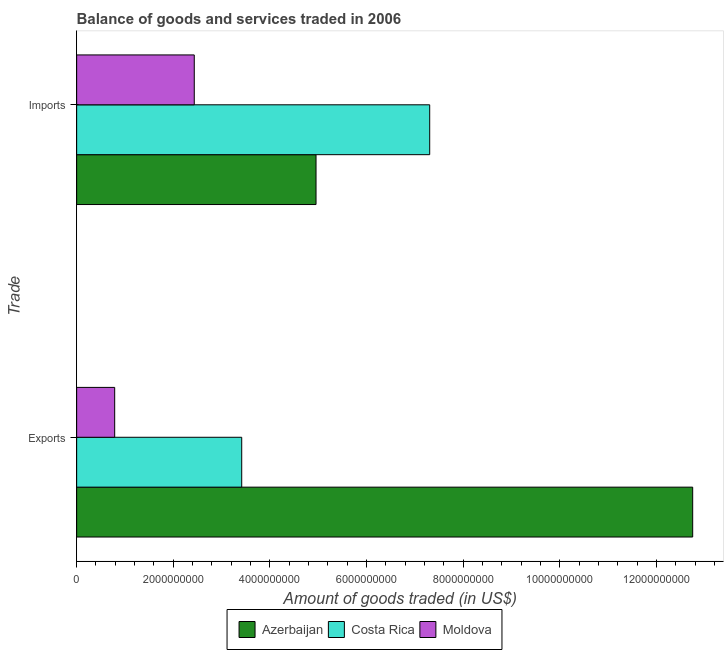How many different coloured bars are there?
Offer a terse response. 3. Are the number of bars on each tick of the Y-axis equal?
Provide a succinct answer. Yes. How many bars are there on the 1st tick from the top?
Offer a very short reply. 3. What is the label of the 1st group of bars from the top?
Make the answer very short. Imports. What is the amount of goods imported in Azerbaijan?
Ensure brevity in your answer.  4.95e+09. Across all countries, what is the maximum amount of goods imported?
Your response must be concise. 7.31e+09. Across all countries, what is the minimum amount of goods exported?
Make the answer very short. 7.87e+08. In which country was the amount of goods exported maximum?
Your response must be concise. Azerbaijan. In which country was the amount of goods imported minimum?
Your answer should be very brief. Moldova. What is the total amount of goods imported in the graph?
Offer a very short reply. 1.47e+1. What is the difference between the amount of goods exported in Costa Rica and that in Azerbaijan?
Your response must be concise. -9.33e+09. What is the difference between the amount of goods exported in Costa Rica and the amount of goods imported in Moldova?
Provide a short and direct response. 9.82e+08. What is the average amount of goods imported per country?
Offer a very short reply. 4.90e+09. What is the difference between the amount of goods imported and amount of goods exported in Moldova?
Keep it short and to the point. 1.65e+09. What is the ratio of the amount of goods imported in Moldova to that in Azerbaijan?
Give a very brief answer. 0.49. Is the amount of goods exported in Moldova less than that in Azerbaijan?
Your answer should be compact. Yes. In how many countries, is the amount of goods imported greater than the average amount of goods imported taken over all countries?
Give a very brief answer. 2. Are all the bars in the graph horizontal?
Your answer should be compact. Yes. What is the difference between two consecutive major ticks on the X-axis?
Offer a terse response. 2.00e+09. Does the graph contain any zero values?
Offer a terse response. No. Does the graph contain grids?
Make the answer very short. No. Where does the legend appear in the graph?
Make the answer very short. Bottom center. How many legend labels are there?
Your response must be concise. 3. How are the legend labels stacked?
Offer a very short reply. Horizontal. What is the title of the graph?
Your response must be concise. Balance of goods and services traded in 2006. Does "Ghana" appear as one of the legend labels in the graph?
Provide a short and direct response. No. What is the label or title of the X-axis?
Make the answer very short. Amount of goods traded (in US$). What is the label or title of the Y-axis?
Your response must be concise. Trade. What is the Amount of goods traded (in US$) in Azerbaijan in Exports?
Give a very brief answer. 1.27e+1. What is the Amount of goods traded (in US$) of Costa Rica in Exports?
Ensure brevity in your answer.  3.42e+09. What is the Amount of goods traded (in US$) of Moldova in Exports?
Keep it short and to the point. 7.87e+08. What is the Amount of goods traded (in US$) in Azerbaijan in Imports?
Keep it short and to the point. 4.95e+09. What is the Amount of goods traded (in US$) in Costa Rica in Imports?
Offer a very short reply. 7.31e+09. What is the Amount of goods traded (in US$) of Moldova in Imports?
Make the answer very short. 2.43e+09. Across all Trade, what is the maximum Amount of goods traded (in US$) of Azerbaijan?
Ensure brevity in your answer.  1.27e+1. Across all Trade, what is the maximum Amount of goods traded (in US$) of Costa Rica?
Offer a very short reply. 7.31e+09. Across all Trade, what is the maximum Amount of goods traded (in US$) in Moldova?
Offer a very short reply. 2.43e+09. Across all Trade, what is the minimum Amount of goods traded (in US$) in Azerbaijan?
Make the answer very short. 4.95e+09. Across all Trade, what is the minimum Amount of goods traded (in US$) of Costa Rica?
Offer a very short reply. 3.42e+09. Across all Trade, what is the minimum Amount of goods traded (in US$) in Moldova?
Your answer should be compact. 7.87e+08. What is the total Amount of goods traded (in US$) of Azerbaijan in the graph?
Give a very brief answer. 1.77e+1. What is the total Amount of goods traded (in US$) in Costa Rica in the graph?
Your response must be concise. 1.07e+1. What is the total Amount of goods traded (in US$) of Moldova in the graph?
Your answer should be compact. 3.22e+09. What is the difference between the Amount of goods traded (in US$) of Azerbaijan in Exports and that in Imports?
Provide a short and direct response. 7.80e+09. What is the difference between the Amount of goods traded (in US$) of Costa Rica in Exports and that in Imports?
Offer a very short reply. -3.89e+09. What is the difference between the Amount of goods traded (in US$) in Moldova in Exports and that in Imports?
Offer a very short reply. -1.65e+09. What is the difference between the Amount of goods traded (in US$) in Azerbaijan in Exports and the Amount of goods traded (in US$) in Costa Rica in Imports?
Make the answer very short. 5.44e+09. What is the difference between the Amount of goods traded (in US$) of Azerbaijan in Exports and the Amount of goods traded (in US$) of Moldova in Imports?
Give a very brief answer. 1.03e+1. What is the difference between the Amount of goods traded (in US$) of Costa Rica in Exports and the Amount of goods traded (in US$) of Moldova in Imports?
Your answer should be very brief. 9.82e+08. What is the average Amount of goods traded (in US$) in Azerbaijan per Trade?
Make the answer very short. 8.85e+09. What is the average Amount of goods traded (in US$) of Costa Rica per Trade?
Ensure brevity in your answer.  5.36e+09. What is the average Amount of goods traded (in US$) in Moldova per Trade?
Give a very brief answer. 1.61e+09. What is the difference between the Amount of goods traded (in US$) of Azerbaijan and Amount of goods traded (in US$) of Costa Rica in Exports?
Provide a short and direct response. 9.33e+09. What is the difference between the Amount of goods traded (in US$) of Azerbaijan and Amount of goods traded (in US$) of Moldova in Exports?
Provide a short and direct response. 1.20e+1. What is the difference between the Amount of goods traded (in US$) in Costa Rica and Amount of goods traded (in US$) in Moldova in Exports?
Offer a very short reply. 2.63e+09. What is the difference between the Amount of goods traded (in US$) in Azerbaijan and Amount of goods traded (in US$) in Costa Rica in Imports?
Ensure brevity in your answer.  -2.35e+09. What is the difference between the Amount of goods traded (in US$) of Azerbaijan and Amount of goods traded (in US$) of Moldova in Imports?
Your response must be concise. 2.52e+09. What is the difference between the Amount of goods traded (in US$) in Costa Rica and Amount of goods traded (in US$) in Moldova in Imports?
Provide a succinct answer. 4.87e+09. What is the ratio of the Amount of goods traded (in US$) in Azerbaijan in Exports to that in Imports?
Offer a terse response. 2.57. What is the ratio of the Amount of goods traded (in US$) in Costa Rica in Exports to that in Imports?
Offer a very short reply. 0.47. What is the ratio of the Amount of goods traded (in US$) of Moldova in Exports to that in Imports?
Your answer should be very brief. 0.32. What is the difference between the highest and the second highest Amount of goods traded (in US$) of Azerbaijan?
Ensure brevity in your answer.  7.80e+09. What is the difference between the highest and the second highest Amount of goods traded (in US$) in Costa Rica?
Your response must be concise. 3.89e+09. What is the difference between the highest and the second highest Amount of goods traded (in US$) in Moldova?
Provide a succinct answer. 1.65e+09. What is the difference between the highest and the lowest Amount of goods traded (in US$) of Azerbaijan?
Your answer should be very brief. 7.80e+09. What is the difference between the highest and the lowest Amount of goods traded (in US$) of Costa Rica?
Ensure brevity in your answer.  3.89e+09. What is the difference between the highest and the lowest Amount of goods traded (in US$) of Moldova?
Your answer should be compact. 1.65e+09. 